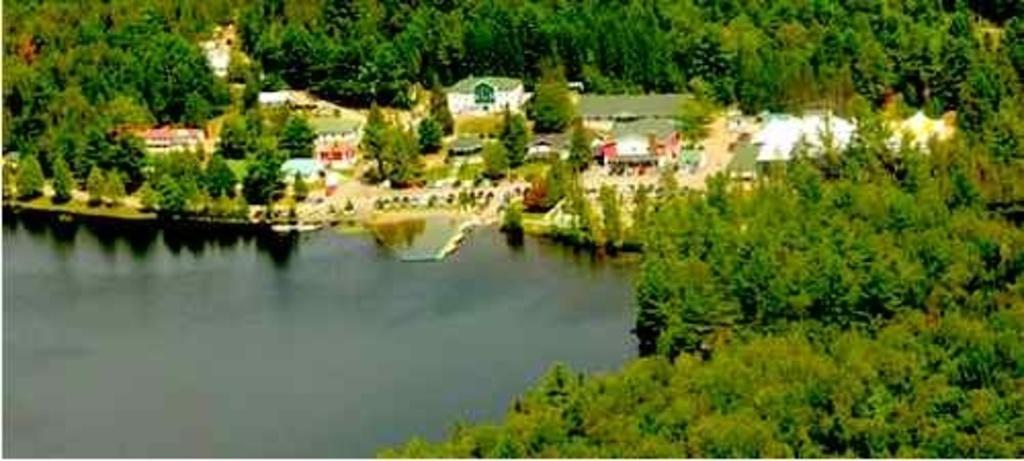Please provide a concise description of this image. This is an aerial view. In this picture we can see the buildings, trees, roofs, ground, road and water. 